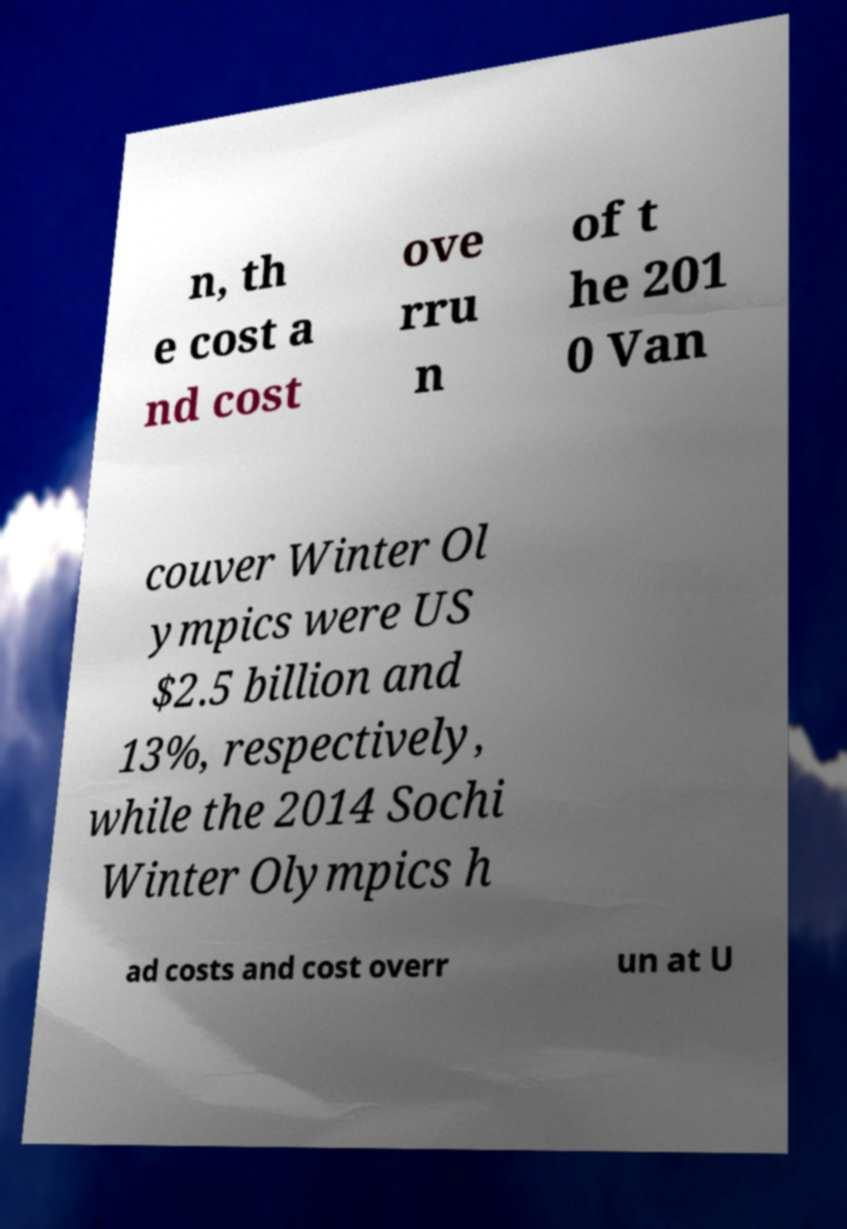Could you assist in decoding the text presented in this image and type it out clearly? n, th e cost a nd cost ove rru n of t he 201 0 Van couver Winter Ol ympics were US $2.5 billion and 13%, respectively, while the 2014 Sochi Winter Olympics h ad costs and cost overr un at U 